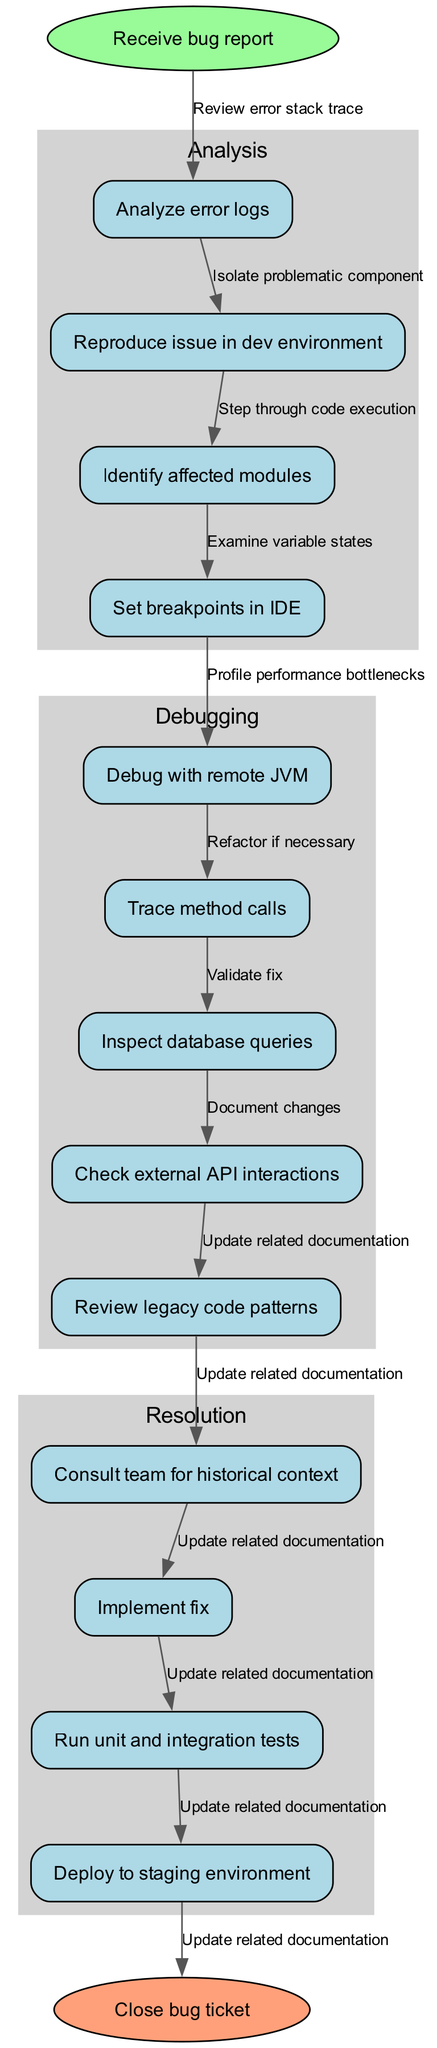What is the starting node of the debugging process? The starting node of the diagram is labeled "Receive bug report," indicating the initial action taken when a bug is reported.
Answer: Receive bug report How many nodes are there in the diagram? The diagram has a total of 13 nodes, which includes the start node, all processing nodes, and the end node.
Answer: 13 What action follows "Analyze error logs"? The action that follows "Analyze error logs" in the flow is "Reproduce issue in dev environment," which is the next step taken after logging analysis.
Answer: Reproduce issue in dev environment What is the last step before closing the bug ticket? Before closing the bug ticket, the last step is "Document changes," which is essential for keeping track of what fixes have been made.
Answer: Document changes Which modules are involved in the debugging process? The nodes that identify interventions in the debugging process include "Identify affected modules," which highlights the importance of recognizing which parts of the application require attention.
Answer: Identify affected modules What is the purpose of "Set breakpoints in IDE"? The purpose of "Set breakpoints in IDE" is to allow the developer to pause execution of the code at specified lines so they can analyze the flow and state during debugging.
Answer: Debugging How many edges connect the nodes in the debugging process? There are 12 edges that connect the nodes, as each action leads to the next step until the process concludes at the end node.
Answer: 12 What does the cluster labeled 'Resolution' encompass? The 'Resolution' cluster includes the steps related to fixing the identified issues, with nodes such as "Implement fix," "Run unit and integration tests," and "Deploy to staging environment."
Answer: Resolution steps What does "Consult team for historical context" contribute to the debugging process? Consulting the team for historical context is crucial for gaining insights into past issues, which may provide guidance for the current problem being debugged.
Answer: Contextual insights 